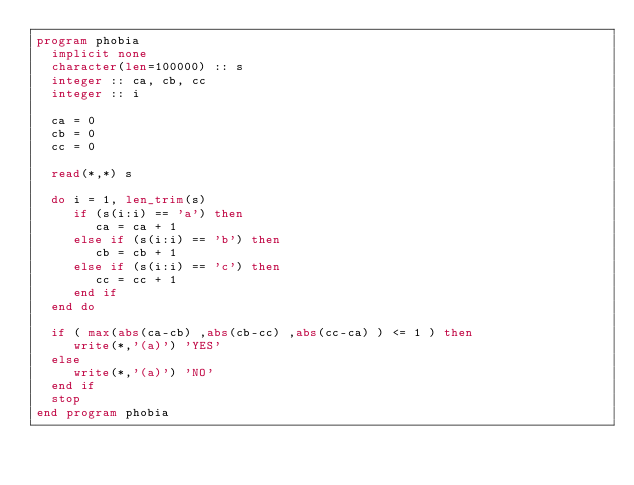<code> <loc_0><loc_0><loc_500><loc_500><_FORTRAN_>program phobia
  implicit none
  character(len=100000) :: s
  integer :: ca, cb, cc
  integer :: i

  ca = 0
  cb = 0
  cc = 0
 
  read(*,*) s

  do i = 1, len_trim(s)
     if (s(i:i) == 'a') then
        ca = ca + 1
     else if (s(i:i) == 'b') then
        cb = cb + 1
     else if (s(i:i) == 'c') then
        cc = cc + 1
     end if
  end do

  if ( max(abs(ca-cb) ,abs(cb-cc) ,abs(cc-ca) ) <= 1 ) then
     write(*,'(a)') 'YES'
  else
     write(*,'(a)') 'NO'
  end if
  stop
end program phobia
</code> 